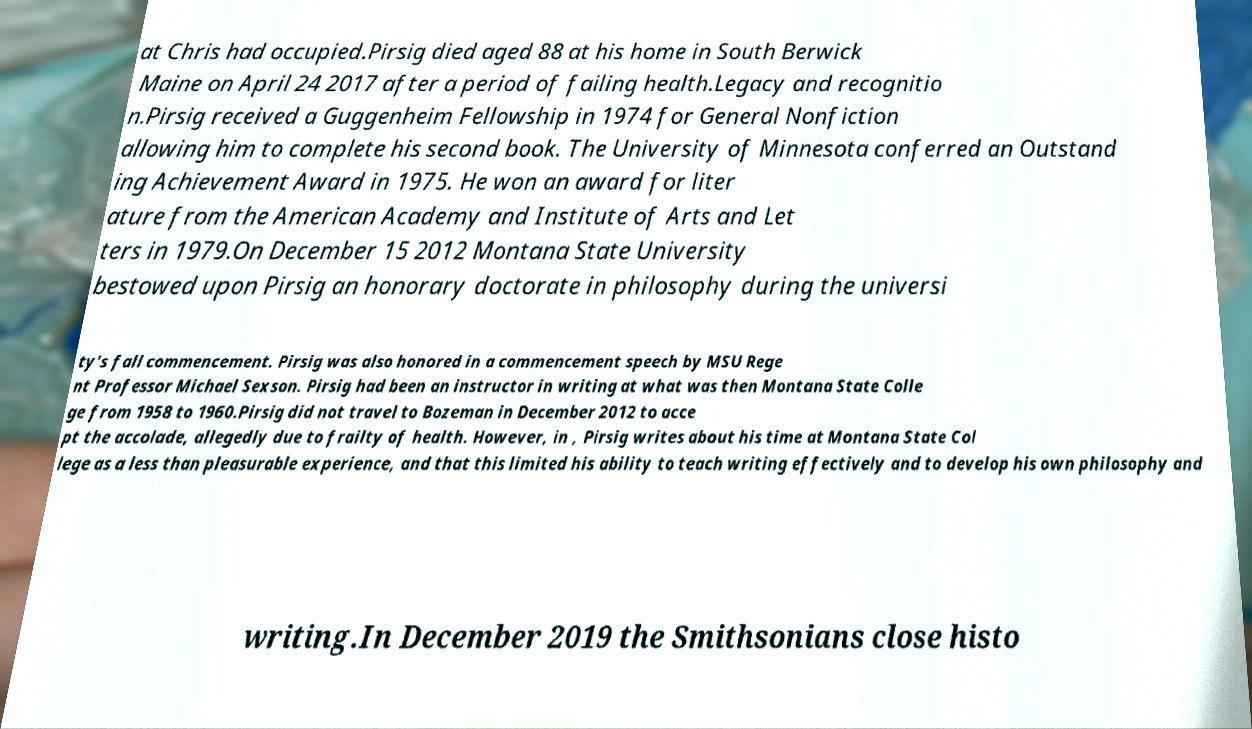I need the written content from this picture converted into text. Can you do that? at Chris had occupied.Pirsig died aged 88 at his home in South Berwick Maine on April 24 2017 after a period of failing health.Legacy and recognitio n.Pirsig received a Guggenheim Fellowship in 1974 for General Nonfiction allowing him to complete his second book. The University of Minnesota conferred an Outstand ing Achievement Award in 1975. He won an award for liter ature from the American Academy and Institute of Arts and Let ters in 1979.On December 15 2012 Montana State University bestowed upon Pirsig an honorary doctorate in philosophy during the universi ty's fall commencement. Pirsig was also honored in a commencement speech by MSU Rege nt Professor Michael Sexson. Pirsig had been an instructor in writing at what was then Montana State Colle ge from 1958 to 1960.Pirsig did not travel to Bozeman in December 2012 to acce pt the accolade, allegedly due to frailty of health. However, in , Pirsig writes about his time at Montana State Col lege as a less than pleasurable experience, and that this limited his ability to teach writing effectively and to develop his own philosophy and writing.In December 2019 the Smithsonians close histo 